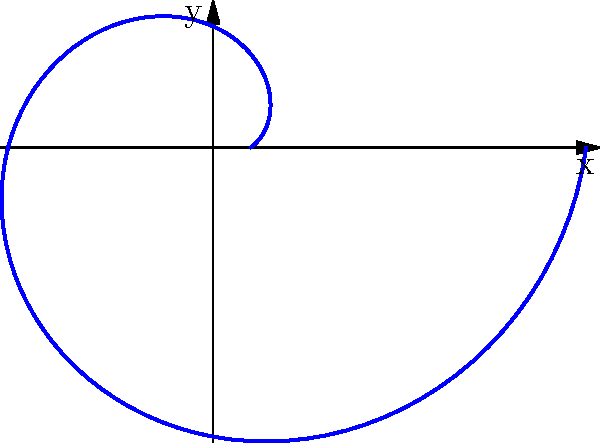Given a spiral defined by the polar equation $r(\theta) = 0.1 + 0.9\theta/(2\pi)$ for $0 \leq \theta \leq 2\pi$, write a C# method using OData to compute the perimeter of the spiral. The perimeter is given by the formula:

$$P = \int_0^{2\pi} \sqrt{r^2 + \left(\frac{dr}{d\theta}\right)^2} d\theta$$

Assume you have access to an OData service that provides numerical integration capabilities. How would you structure your C# method to leverage OData for this computation? To solve this problem, we'll follow these steps:

1. Define the function for $r(\theta)$ and its derivative $\frac{dr}{d\theta}$.
2. Create the integrand function $\sqrt{r^2 + \left(\frac{dr}{d\theta}\right)^2}$.
3. Use OData to perform the numerical integration.

Here's a C# method that accomplishes this:

```csharp
public async Task<double> ComputeSpiralPerimeter(IODataClient client)
{
    // Define the functions
    Func<double, double> r = theta => 0.1 + 0.9 * theta / (2 * Math.PI);
    Func<double, double> dr = theta => 0.9 / (2 * Math.PI);

    // Define the integrand
    Func<double, double> integrand = theta => 
        Math.Sqrt(Math.Pow(r(theta), 2) + Math.Pow(dr(theta), 2));

    // Create OData query for numerical integration
    var result = await client.For("NumericalIntegration")
        .Function("Integrate")
        .Parameter("function", integrand)
        .Parameter("lowerBound", 0)
        .Parameter("upperBound", 2 * Math.PI)
        .Parameter("method", "Simpson")
        .ExecuteAsSingleAsync<double>();

    return result;
}
```

This method assumes that the OData service has a `NumericalIntegration` endpoint with an `Integrate` function that takes the integrand, lower and upper bounds, and integration method as parameters.

The key steps are:
1. Define `r(θ)` and `dr/dθ` as C# functions.
2. Create the integrand function combining these.
3. Use OData to call a numerical integration service, passing the integrand and integration bounds.
4. Return the result of the integration, which is the perimeter of the spiral.

This approach leverages OData's ability to handle complex computations on the server-side, reducing the computational load on the client and potentially improving performance for complex integrals.
Answer: Async OData method using numerical integration service to compute spiral perimeter 